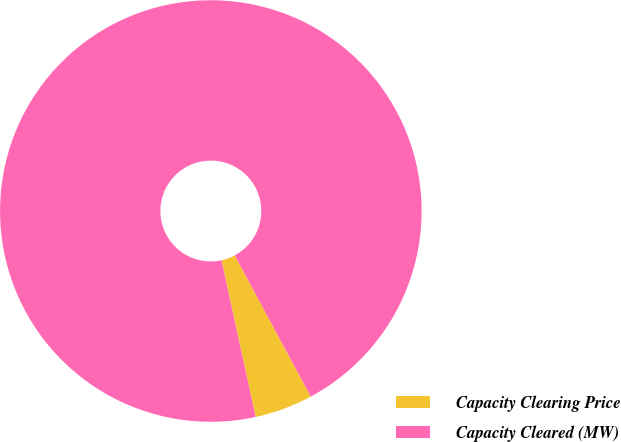Convert chart to OTSL. <chart><loc_0><loc_0><loc_500><loc_500><pie_chart><fcel>Capacity Clearing Price<fcel>Capacity Cleared (MW)<nl><fcel>4.45%<fcel>95.55%<nl></chart> 